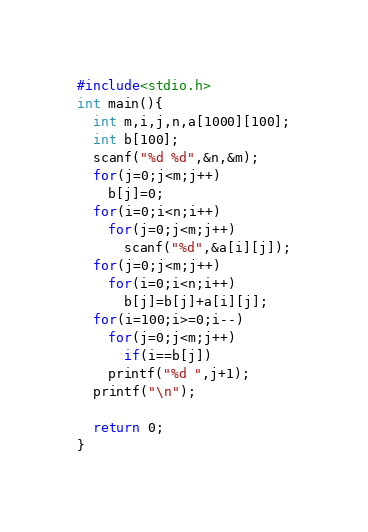Convert code to text. <code><loc_0><loc_0><loc_500><loc_500><_C_>#include<stdio.h>
int main(){
  int m,i,j,n,a[1000][100];
  int b[100];
  scanf("%d %d",&n,&m);
  for(j=0;j<m;j++)
    b[j]=0;
  for(i=0;i<n;i++)
    for(j=0;j<m;j++)
      scanf("%d",&a[i][j]);
  for(j=0;j<m;j++)
    for(i=0;i<n;i++)
      b[j]=b[j]+a[i][j];
  for(i=100;i>=0;i--)
    for(j=0;j<m;j++)
      if(i==b[j])
	printf("%d ",j+1);
  printf("\n");

  return 0;
}</code> 